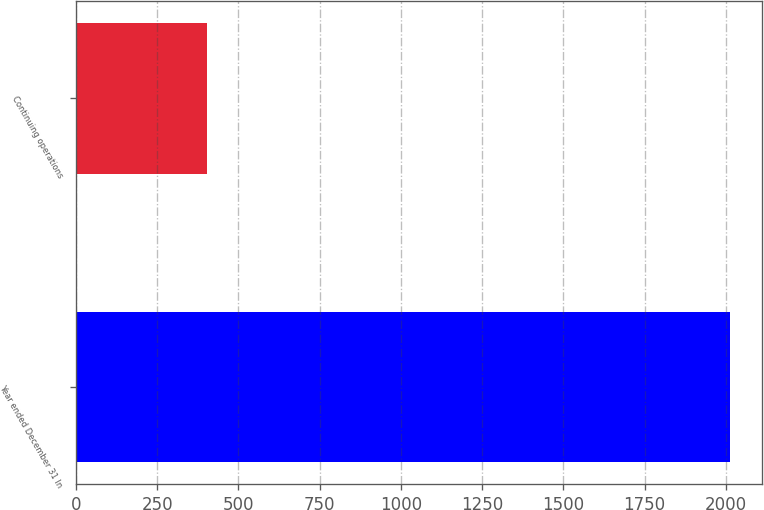Convert chart to OTSL. <chart><loc_0><loc_0><loc_500><loc_500><bar_chart><fcel>Year ended December 31 In<fcel>Continuing operations<nl><fcel>2012<fcel>405<nl></chart> 